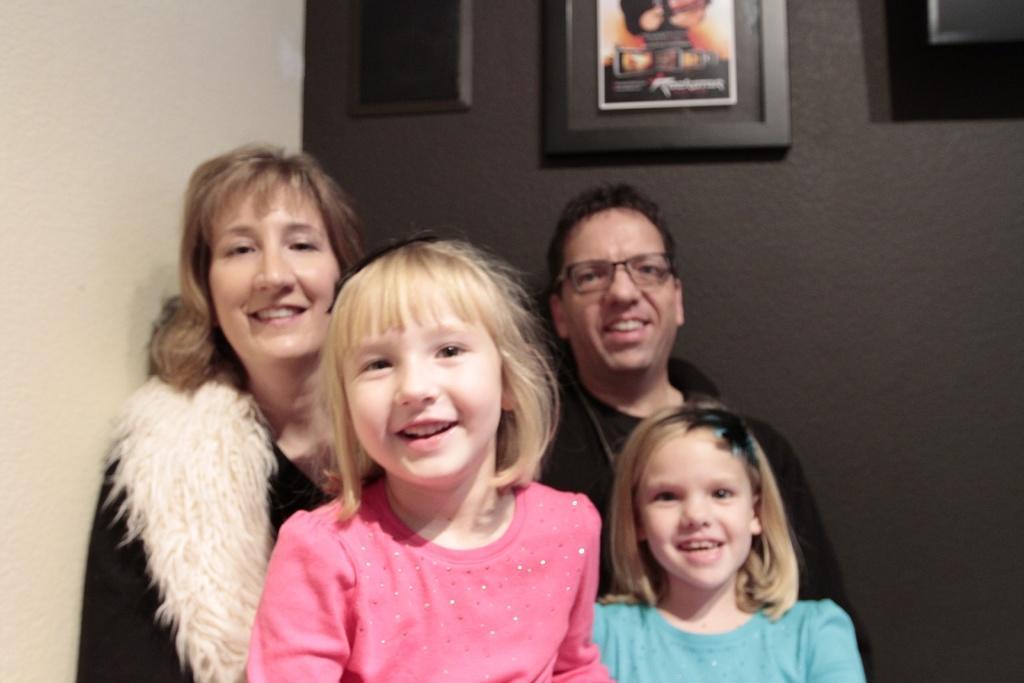Please provide a concise description of this image. In this image it seems like it is a family where there are two kids and a couple. In the background there is a wall on which there are three frames. 